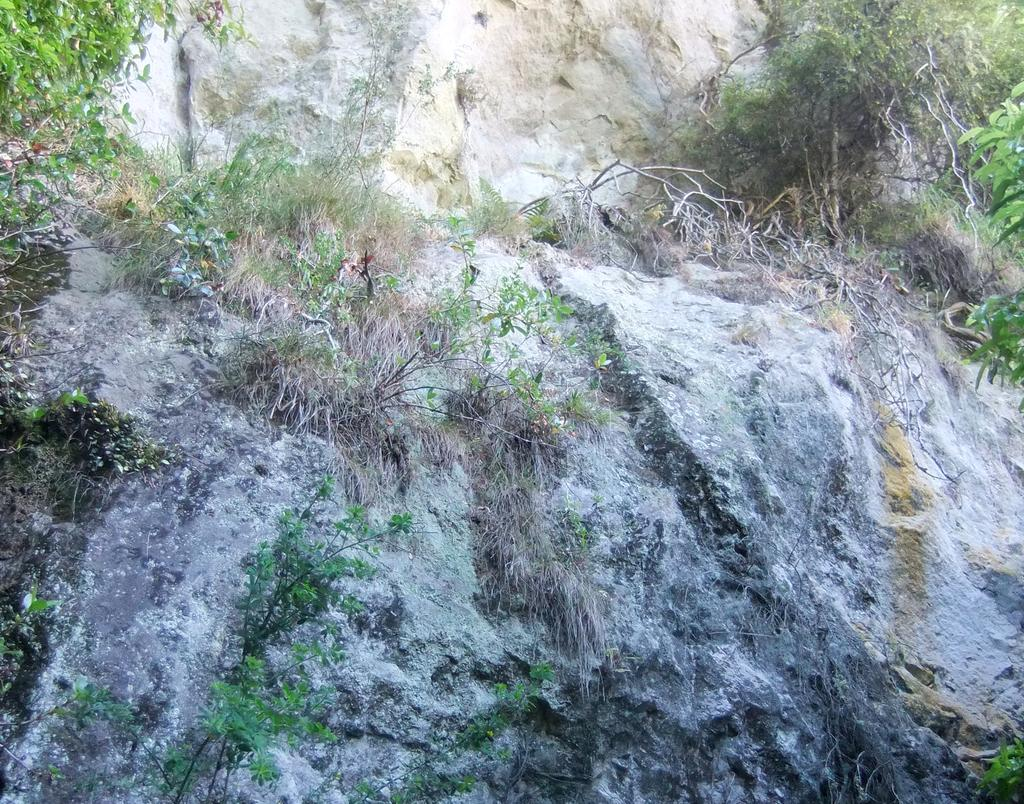What type of vegetation can be seen in the image? There are plants and trees in the image. Where are the plants and trees located? The plants and trees are on rocks. What type of dirt is visible on the plants and trees in the image? There is no dirt visible on the plants and trees in the image; they are on rocks. Can you tell me how many experts are present in the image? There is no expert present in the image; it features plants and trees on rocks. 